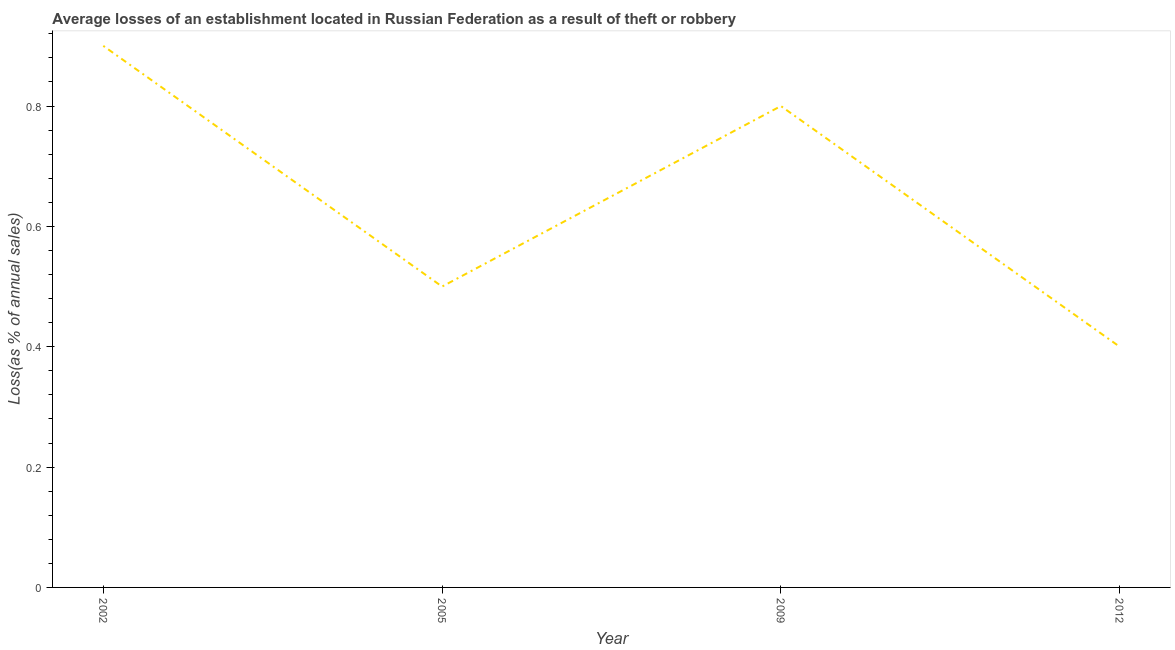What is the losses due to theft in 2012?
Your response must be concise. 0.4. Across all years, what is the minimum losses due to theft?
Provide a short and direct response. 0.4. In which year was the losses due to theft maximum?
Ensure brevity in your answer.  2002. In which year was the losses due to theft minimum?
Ensure brevity in your answer.  2012. What is the average losses due to theft per year?
Your answer should be compact. 0.65. What is the median losses due to theft?
Provide a short and direct response. 0.65. Do a majority of the years between 2009 and 2005 (inclusive) have losses due to theft greater than 0.32 %?
Offer a terse response. No. What is the ratio of the losses due to theft in 2002 to that in 2012?
Provide a short and direct response. 2.25. Is the losses due to theft in 2005 less than that in 2009?
Ensure brevity in your answer.  Yes. Is the difference between the losses due to theft in 2005 and 2009 greater than the difference between any two years?
Ensure brevity in your answer.  No. What is the difference between the highest and the second highest losses due to theft?
Make the answer very short. 0.1. What is the difference between two consecutive major ticks on the Y-axis?
Offer a very short reply. 0.2. Does the graph contain any zero values?
Offer a very short reply. No. Does the graph contain grids?
Your answer should be compact. No. What is the title of the graph?
Your response must be concise. Average losses of an establishment located in Russian Federation as a result of theft or robbery. What is the label or title of the X-axis?
Give a very brief answer. Year. What is the label or title of the Y-axis?
Ensure brevity in your answer.  Loss(as % of annual sales). What is the Loss(as % of annual sales) in 2002?
Your answer should be very brief. 0.9. What is the Loss(as % of annual sales) of 2012?
Your answer should be very brief. 0.4. What is the difference between the Loss(as % of annual sales) in 2002 and 2005?
Ensure brevity in your answer.  0.4. What is the difference between the Loss(as % of annual sales) in 2005 and 2009?
Your response must be concise. -0.3. What is the difference between the Loss(as % of annual sales) in 2005 and 2012?
Provide a short and direct response. 0.1. What is the difference between the Loss(as % of annual sales) in 2009 and 2012?
Your answer should be compact. 0.4. What is the ratio of the Loss(as % of annual sales) in 2002 to that in 2005?
Give a very brief answer. 1.8. What is the ratio of the Loss(as % of annual sales) in 2002 to that in 2012?
Your response must be concise. 2.25. What is the ratio of the Loss(as % of annual sales) in 2005 to that in 2012?
Your answer should be very brief. 1.25. 